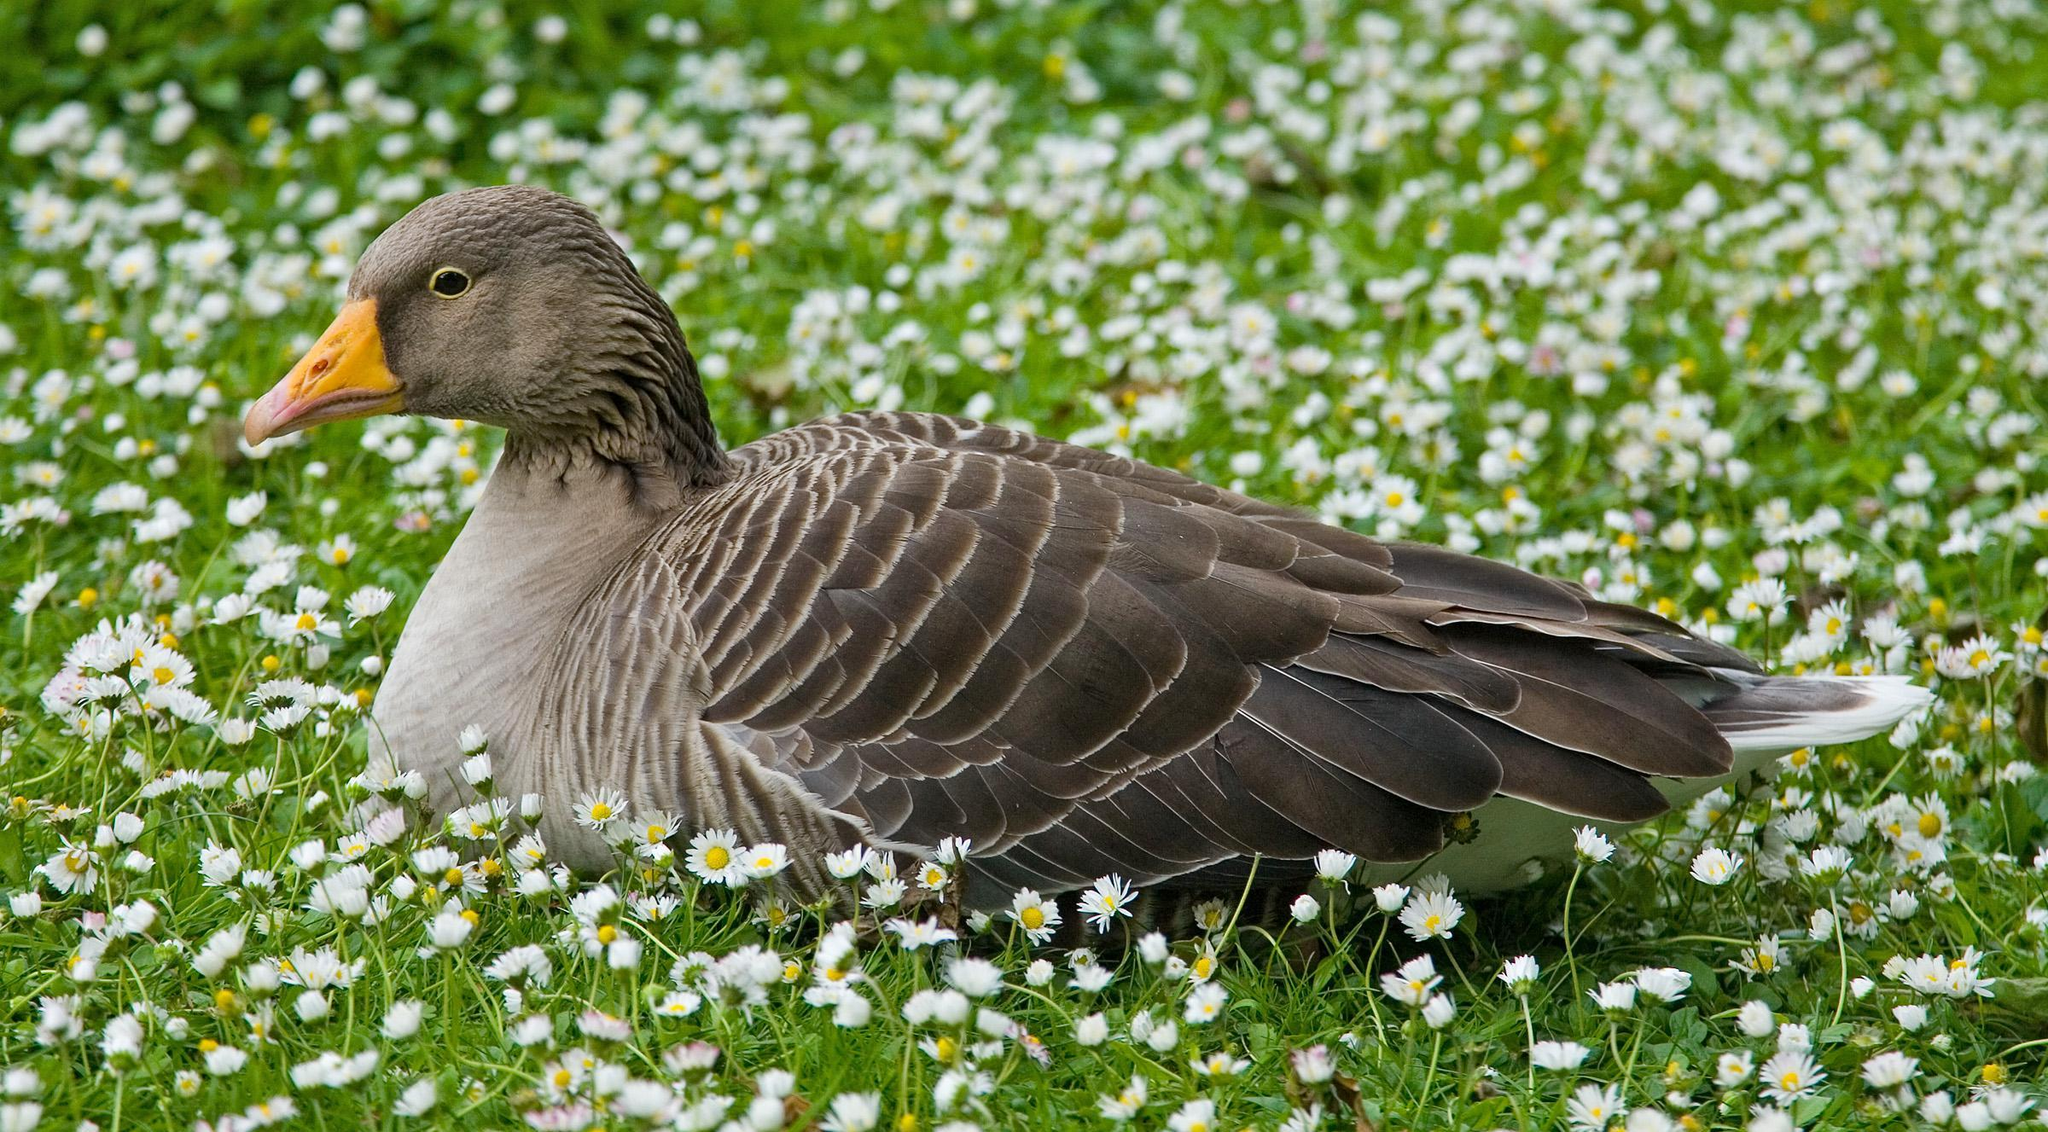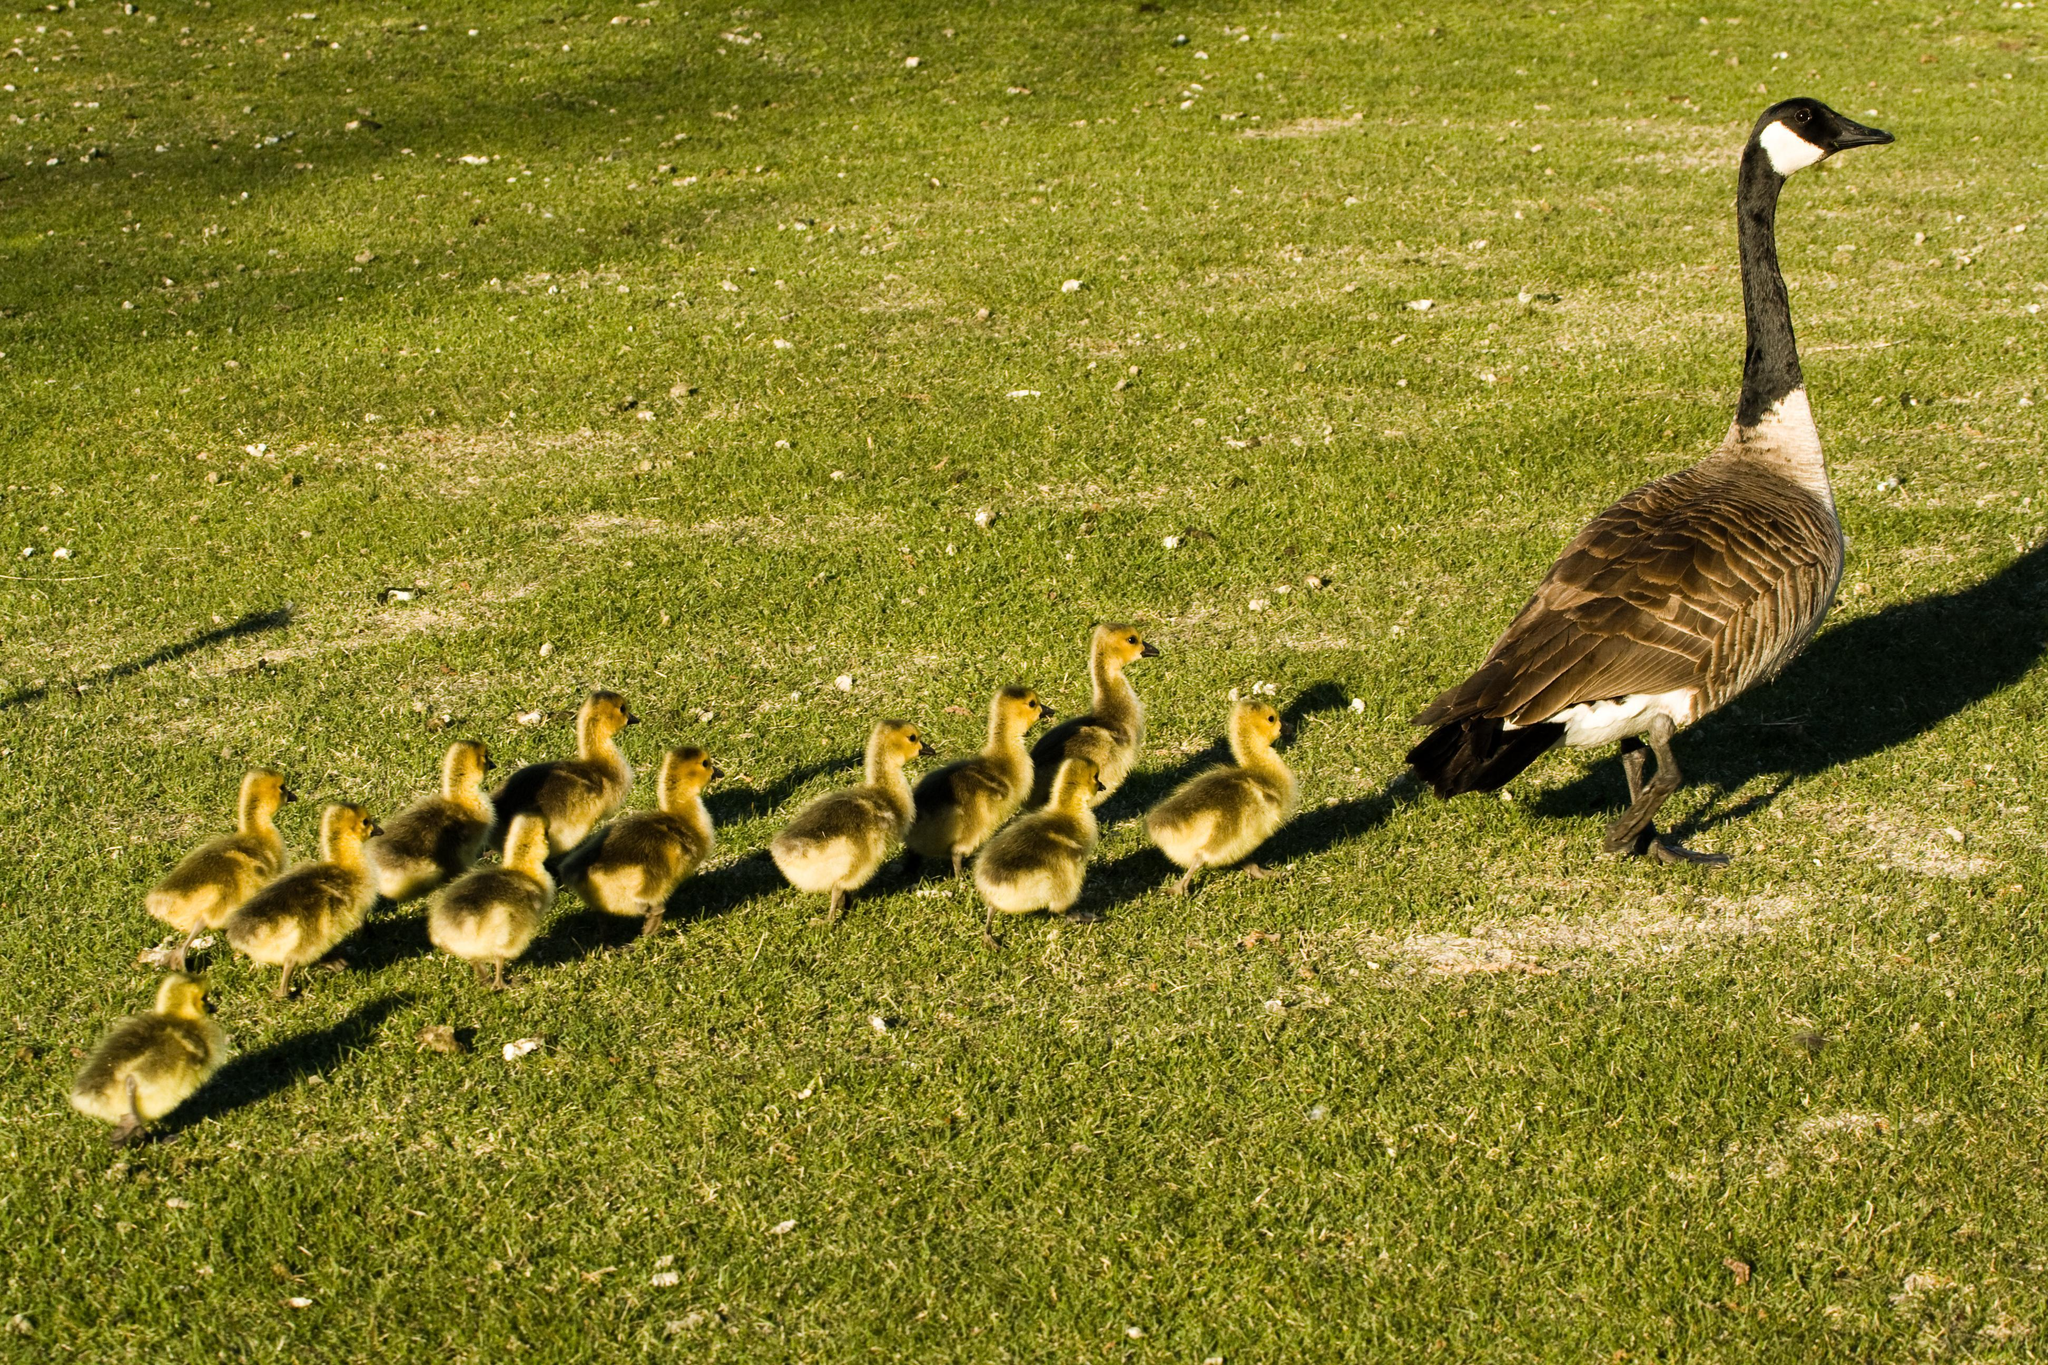The first image is the image on the left, the second image is the image on the right. Evaluate the accuracy of this statement regarding the images: "The right image shows birds standing in grass.". Is it true? Answer yes or no. Yes. The first image is the image on the left, the second image is the image on the right. Assess this claim about the two images: "An image shows a group of water fowl all walking in the same direction.". Correct or not? Answer yes or no. Yes. 